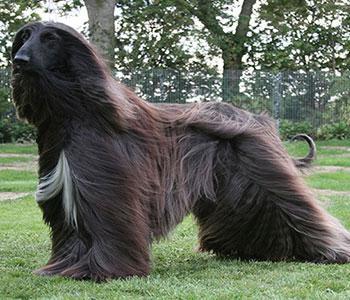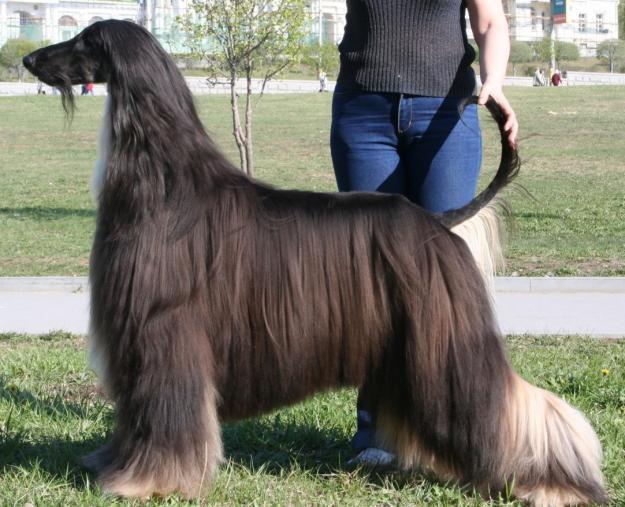The first image is the image on the left, the second image is the image on the right. For the images displayed, is the sentence "There is a person standing with the dog in the image on the right." factually correct? Answer yes or no. Yes. The first image is the image on the left, the second image is the image on the right. Assess this claim about the two images: "A person in blue jeans is standing behind a dark afghan hound facing leftward.". Correct or not? Answer yes or no. Yes. 